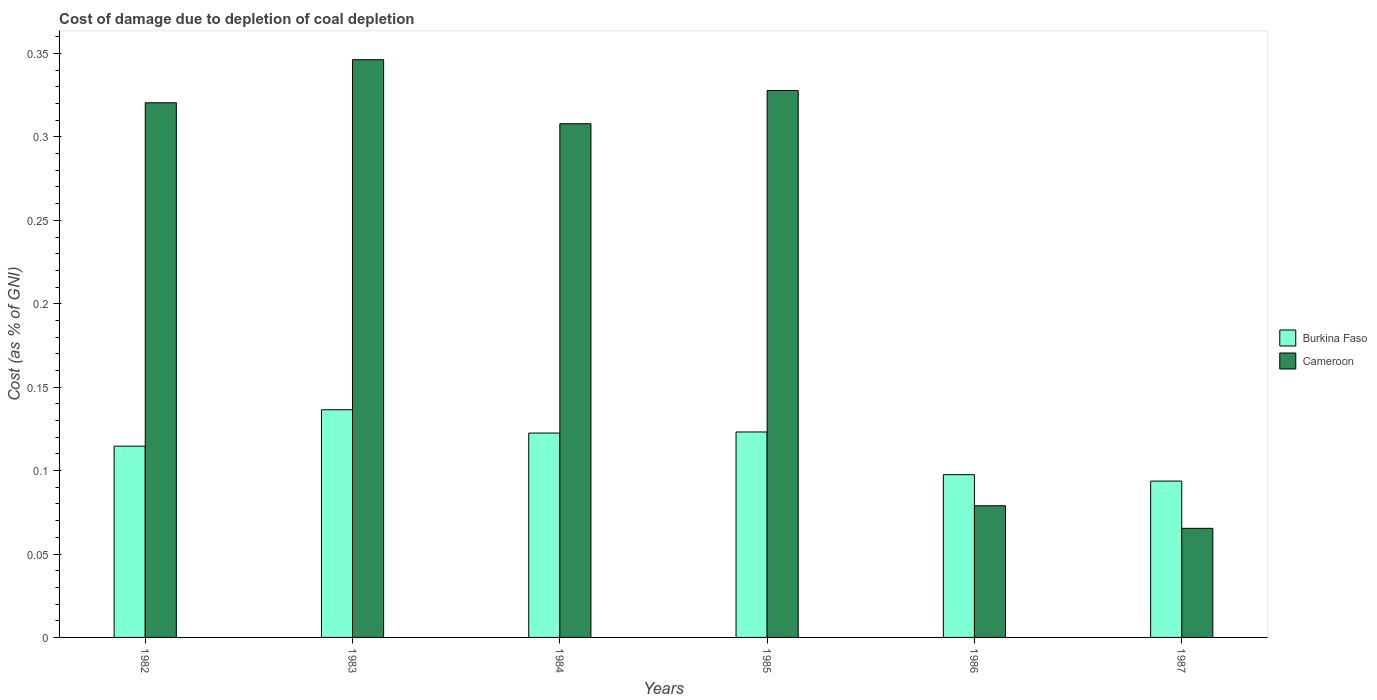How many groups of bars are there?
Your answer should be compact. 6. Are the number of bars per tick equal to the number of legend labels?
Provide a short and direct response. Yes. Are the number of bars on each tick of the X-axis equal?
Give a very brief answer. Yes. How many bars are there on the 3rd tick from the left?
Offer a very short reply. 2. What is the label of the 3rd group of bars from the left?
Your response must be concise. 1984. In how many cases, is the number of bars for a given year not equal to the number of legend labels?
Your response must be concise. 0. What is the cost of damage caused due to coal depletion in Burkina Faso in 1986?
Provide a succinct answer. 0.1. Across all years, what is the maximum cost of damage caused due to coal depletion in Burkina Faso?
Offer a terse response. 0.14. Across all years, what is the minimum cost of damage caused due to coal depletion in Burkina Faso?
Your response must be concise. 0.09. In which year was the cost of damage caused due to coal depletion in Burkina Faso minimum?
Your response must be concise. 1987. What is the total cost of damage caused due to coal depletion in Cameroon in the graph?
Offer a terse response. 1.45. What is the difference between the cost of damage caused due to coal depletion in Cameroon in 1985 and that in 1987?
Provide a short and direct response. 0.26. What is the difference between the cost of damage caused due to coal depletion in Cameroon in 1986 and the cost of damage caused due to coal depletion in Burkina Faso in 1987?
Keep it short and to the point. -0.01. What is the average cost of damage caused due to coal depletion in Cameroon per year?
Ensure brevity in your answer.  0.24. In the year 1987, what is the difference between the cost of damage caused due to coal depletion in Cameroon and cost of damage caused due to coal depletion in Burkina Faso?
Your response must be concise. -0.03. In how many years, is the cost of damage caused due to coal depletion in Burkina Faso greater than 0.32000000000000006 %?
Make the answer very short. 0. What is the ratio of the cost of damage caused due to coal depletion in Cameroon in 1984 to that in 1987?
Provide a succinct answer. 4.71. Is the cost of damage caused due to coal depletion in Burkina Faso in 1982 less than that in 1987?
Your answer should be very brief. No. What is the difference between the highest and the second highest cost of damage caused due to coal depletion in Burkina Faso?
Keep it short and to the point. 0.01. What is the difference between the highest and the lowest cost of damage caused due to coal depletion in Cameroon?
Provide a short and direct response. 0.28. Is the sum of the cost of damage caused due to coal depletion in Burkina Faso in 1986 and 1987 greater than the maximum cost of damage caused due to coal depletion in Cameroon across all years?
Provide a short and direct response. No. What does the 1st bar from the left in 1985 represents?
Ensure brevity in your answer.  Burkina Faso. What does the 2nd bar from the right in 1987 represents?
Provide a short and direct response. Burkina Faso. How many bars are there?
Provide a succinct answer. 12. What is the difference between two consecutive major ticks on the Y-axis?
Your answer should be very brief. 0.05. Are the values on the major ticks of Y-axis written in scientific E-notation?
Provide a short and direct response. No. Does the graph contain grids?
Your answer should be very brief. No. What is the title of the graph?
Offer a terse response. Cost of damage due to depletion of coal depletion. Does "Fragile and conflict affected situations" appear as one of the legend labels in the graph?
Give a very brief answer. No. What is the label or title of the Y-axis?
Ensure brevity in your answer.  Cost (as % of GNI). What is the Cost (as % of GNI) in Burkina Faso in 1982?
Give a very brief answer. 0.11. What is the Cost (as % of GNI) in Cameroon in 1982?
Ensure brevity in your answer.  0.32. What is the Cost (as % of GNI) in Burkina Faso in 1983?
Your answer should be compact. 0.14. What is the Cost (as % of GNI) in Cameroon in 1983?
Provide a short and direct response. 0.35. What is the Cost (as % of GNI) of Burkina Faso in 1984?
Your answer should be compact. 0.12. What is the Cost (as % of GNI) in Cameroon in 1984?
Offer a very short reply. 0.31. What is the Cost (as % of GNI) in Burkina Faso in 1985?
Provide a short and direct response. 0.12. What is the Cost (as % of GNI) of Cameroon in 1985?
Your answer should be compact. 0.33. What is the Cost (as % of GNI) in Burkina Faso in 1986?
Keep it short and to the point. 0.1. What is the Cost (as % of GNI) in Cameroon in 1986?
Offer a very short reply. 0.08. What is the Cost (as % of GNI) in Burkina Faso in 1987?
Give a very brief answer. 0.09. What is the Cost (as % of GNI) of Cameroon in 1987?
Your answer should be very brief. 0.07. Across all years, what is the maximum Cost (as % of GNI) in Burkina Faso?
Offer a very short reply. 0.14. Across all years, what is the maximum Cost (as % of GNI) of Cameroon?
Your answer should be very brief. 0.35. Across all years, what is the minimum Cost (as % of GNI) of Burkina Faso?
Offer a very short reply. 0.09. Across all years, what is the minimum Cost (as % of GNI) in Cameroon?
Your response must be concise. 0.07. What is the total Cost (as % of GNI) of Burkina Faso in the graph?
Offer a terse response. 0.69. What is the total Cost (as % of GNI) of Cameroon in the graph?
Your answer should be compact. 1.45. What is the difference between the Cost (as % of GNI) in Burkina Faso in 1982 and that in 1983?
Give a very brief answer. -0.02. What is the difference between the Cost (as % of GNI) in Cameroon in 1982 and that in 1983?
Provide a succinct answer. -0.03. What is the difference between the Cost (as % of GNI) of Burkina Faso in 1982 and that in 1984?
Your answer should be compact. -0.01. What is the difference between the Cost (as % of GNI) of Cameroon in 1982 and that in 1984?
Your answer should be very brief. 0.01. What is the difference between the Cost (as % of GNI) of Burkina Faso in 1982 and that in 1985?
Offer a terse response. -0.01. What is the difference between the Cost (as % of GNI) of Cameroon in 1982 and that in 1985?
Provide a short and direct response. -0.01. What is the difference between the Cost (as % of GNI) in Burkina Faso in 1982 and that in 1986?
Your answer should be very brief. 0.02. What is the difference between the Cost (as % of GNI) of Cameroon in 1982 and that in 1986?
Your response must be concise. 0.24. What is the difference between the Cost (as % of GNI) in Burkina Faso in 1982 and that in 1987?
Ensure brevity in your answer.  0.02. What is the difference between the Cost (as % of GNI) in Cameroon in 1982 and that in 1987?
Your answer should be compact. 0.26. What is the difference between the Cost (as % of GNI) in Burkina Faso in 1983 and that in 1984?
Your answer should be compact. 0.01. What is the difference between the Cost (as % of GNI) of Cameroon in 1983 and that in 1984?
Offer a terse response. 0.04. What is the difference between the Cost (as % of GNI) in Burkina Faso in 1983 and that in 1985?
Ensure brevity in your answer.  0.01. What is the difference between the Cost (as % of GNI) of Cameroon in 1983 and that in 1985?
Offer a terse response. 0.02. What is the difference between the Cost (as % of GNI) in Burkina Faso in 1983 and that in 1986?
Make the answer very short. 0.04. What is the difference between the Cost (as % of GNI) in Cameroon in 1983 and that in 1986?
Your answer should be very brief. 0.27. What is the difference between the Cost (as % of GNI) of Burkina Faso in 1983 and that in 1987?
Give a very brief answer. 0.04. What is the difference between the Cost (as % of GNI) of Cameroon in 1983 and that in 1987?
Ensure brevity in your answer.  0.28. What is the difference between the Cost (as % of GNI) of Burkina Faso in 1984 and that in 1985?
Your answer should be compact. -0. What is the difference between the Cost (as % of GNI) of Cameroon in 1984 and that in 1985?
Your response must be concise. -0.02. What is the difference between the Cost (as % of GNI) of Burkina Faso in 1984 and that in 1986?
Make the answer very short. 0.02. What is the difference between the Cost (as % of GNI) in Cameroon in 1984 and that in 1986?
Your response must be concise. 0.23. What is the difference between the Cost (as % of GNI) in Burkina Faso in 1984 and that in 1987?
Give a very brief answer. 0.03. What is the difference between the Cost (as % of GNI) in Cameroon in 1984 and that in 1987?
Ensure brevity in your answer.  0.24. What is the difference between the Cost (as % of GNI) in Burkina Faso in 1985 and that in 1986?
Keep it short and to the point. 0.03. What is the difference between the Cost (as % of GNI) in Cameroon in 1985 and that in 1986?
Your answer should be compact. 0.25. What is the difference between the Cost (as % of GNI) of Burkina Faso in 1985 and that in 1987?
Your response must be concise. 0.03. What is the difference between the Cost (as % of GNI) of Cameroon in 1985 and that in 1987?
Ensure brevity in your answer.  0.26. What is the difference between the Cost (as % of GNI) of Burkina Faso in 1986 and that in 1987?
Provide a succinct answer. 0. What is the difference between the Cost (as % of GNI) in Cameroon in 1986 and that in 1987?
Give a very brief answer. 0.01. What is the difference between the Cost (as % of GNI) in Burkina Faso in 1982 and the Cost (as % of GNI) in Cameroon in 1983?
Offer a very short reply. -0.23. What is the difference between the Cost (as % of GNI) of Burkina Faso in 1982 and the Cost (as % of GNI) of Cameroon in 1984?
Keep it short and to the point. -0.19. What is the difference between the Cost (as % of GNI) in Burkina Faso in 1982 and the Cost (as % of GNI) in Cameroon in 1985?
Make the answer very short. -0.21. What is the difference between the Cost (as % of GNI) of Burkina Faso in 1982 and the Cost (as % of GNI) of Cameroon in 1986?
Provide a succinct answer. 0.04. What is the difference between the Cost (as % of GNI) in Burkina Faso in 1982 and the Cost (as % of GNI) in Cameroon in 1987?
Give a very brief answer. 0.05. What is the difference between the Cost (as % of GNI) in Burkina Faso in 1983 and the Cost (as % of GNI) in Cameroon in 1984?
Your answer should be compact. -0.17. What is the difference between the Cost (as % of GNI) in Burkina Faso in 1983 and the Cost (as % of GNI) in Cameroon in 1985?
Keep it short and to the point. -0.19. What is the difference between the Cost (as % of GNI) of Burkina Faso in 1983 and the Cost (as % of GNI) of Cameroon in 1986?
Your response must be concise. 0.06. What is the difference between the Cost (as % of GNI) of Burkina Faso in 1983 and the Cost (as % of GNI) of Cameroon in 1987?
Give a very brief answer. 0.07. What is the difference between the Cost (as % of GNI) in Burkina Faso in 1984 and the Cost (as % of GNI) in Cameroon in 1985?
Offer a terse response. -0.21. What is the difference between the Cost (as % of GNI) in Burkina Faso in 1984 and the Cost (as % of GNI) in Cameroon in 1986?
Keep it short and to the point. 0.04. What is the difference between the Cost (as % of GNI) in Burkina Faso in 1984 and the Cost (as % of GNI) in Cameroon in 1987?
Make the answer very short. 0.06. What is the difference between the Cost (as % of GNI) in Burkina Faso in 1985 and the Cost (as % of GNI) in Cameroon in 1986?
Keep it short and to the point. 0.04. What is the difference between the Cost (as % of GNI) in Burkina Faso in 1985 and the Cost (as % of GNI) in Cameroon in 1987?
Your answer should be very brief. 0.06. What is the difference between the Cost (as % of GNI) in Burkina Faso in 1986 and the Cost (as % of GNI) in Cameroon in 1987?
Make the answer very short. 0.03. What is the average Cost (as % of GNI) of Burkina Faso per year?
Your answer should be compact. 0.11. What is the average Cost (as % of GNI) of Cameroon per year?
Your response must be concise. 0.24. In the year 1982, what is the difference between the Cost (as % of GNI) of Burkina Faso and Cost (as % of GNI) of Cameroon?
Give a very brief answer. -0.21. In the year 1983, what is the difference between the Cost (as % of GNI) in Burkina Faso and Cost (as % of GNI) in Cameroon?
Provide a succinct answer. -0.21. In the year 1984, what is the difference between the Cost (as % of GNI) in Burkina Faso and Cost (as % of GNI) in Cameroon?
Provide a short and direct response. -0.19. In the year 1985, what is the difference between the Cost (as % of GNI) of Burkina Faso and Cost (as % of GNI) of Cameroon?
Ensure brevity in your answer.  -0.2. In the year 1986, what is the difference between the Cost (as % of GNI) in Burkina Faso and Cost (as % of GNI) in Cameroon?
Your answer should be very brief. 0.02. In the year 1987, what is the difference between the Cost (as % of GNI) in Burkina Faso and Cost (as % of GNI) in Cameroon?
Your answer should be very brief. 0.03. What is the ratio of the Cost (as % of GNI) in Burkina Faso in 1982 to that in 1983?
Make the answer very short. 0.84. What is the ratio of the Cost (as % of GNI) of Cameroon in 1982 to that in 1983?
Your answer should be very brief. 0.93. What is the ratio of the Cost (as % of GNI) in Burkina Faso in 1982 to that in 1984?
Ensure brevity in your answer.  0.94. What is the ratio of the Cost (as % of GNI) of Cameroon in 1982 to that in 1984?
Ensure brevity in your answer.  1.04. What is the ratio of the Cost (as % of GNI) in Burkina Faso in 1982 to that in 1985?
Your answer should be compact. 0.93. What is the ratio of the Cost (as % of GNI) of Cameroon in 1982 to that in 1985?
Keep it short and to the point. 0.98. What is the ratio of the Cost (as % of GNI) of Burkina Faso in 1982 to that in 1986?
Offer a very short reply. 1.18. What is the ratio of the Cost (as % of GNI) of Cameroon in 1982 to that in 1986?
Provide a succinct answer. 4.06. What is the ratio of the Cost (as % of GNI) in Burkina Faso in 1982 to that in 1987?
Provide a succinct answer. 1.22. What is the ratio of the Cost (as % of GNI) in Cameroon in 1982 to that in 1987?
Provide a succinct answer. 4.9. What is the ratio of the Cost (as % of GNI) of Burkina Faso in 1983 to that in 1984?
Offer a terse response. 1.11. What is the ratio of the Cost (as % of GNI) of Cameroon in 1983 to that in 1984?
Ensure brevity in your answer.  1.12. What is the ratio of the Cost (as % of GNI) in Burkina Faso in 1983 to that in 1985?
Offer a terse response. 1.11. What is the ratio of the Cost (as % of GNI) in Cameroon in 1983 to that in 1985?
Provide a succinct answer. 1.06. What is the ratio of the Cost (as % of GNI) of Burkina Faso in 1983 to that in 1986?
Give a very brief answer. 1.4. What is the ratio of the Cost (as % of GNI) in Cameroon in 1983 to that in 1986?
Provide a short and direct response. 4.39. What is the ratio of the Cost (as % of GNI) of Burkina Faso in 1983 to that in 1987?
Give a very brief answer. 1.46. What is the ratio of the Cost (as % of GNI) in Cameroon in 1983 to that in 1987?
Ensure brevity in your answer.  5.3. What is the ratio of the Cost (as % of GNI) in Burkina Faso in 1984 to that in 1985?
Provide a succinct answer. 0.99. What is the ratio of the Cost (as % of GNI) of Cameroon in 1984 to that in 1985?
Give a very brief answer. 0.94. What is the ratio of the Cost (as % of GNI) in Burkina Faso in 1984 to that in 1986?
Your response must be concise. 1.26. What is the ratio of the Cost (as % of GNI) of Cameroon in 1984 to that in 1986?
Your response must be concise. 3.9. What is the ratio of the Cost (as % of GNI) of Burkina Faso in 1984 to that in 1987?
Make the answer very short. 1.31. What is the ratio of the Cost (as % of GNI) in Cameroon in 1984 to that in 1987?
Offer a terse response. 4.71. What is the ratio of the Cost (as % of GNI) of Burkina Faso in 1985 to that in 1986?
Provide a short and direct response. 1.26. What is the ratio of the Cost (as % of GNI) of Cameroon in 1985 to that in 1986?
Provide a short and direct response. 4.15. What is the ratio of the Cost (as % of GNI) of Burkina Faso in 1985 to that in 1987?
Give a very brief answer. 1.31. What is the ratio of the Cost (as % of GNI) of Cameroon in 1985 to that in 1987?
Your answer should be compact. 5.01. What is the ratio of the Cost (as % of GNI) in Burkina Faso in 1986 to that in 1987?
Keep it short and to the point. 1.04. What is the ratio of the Cost (as % of GNI) of Cameroon in 1986 to that in 1987?
Your answer should be compact. 1.21. What is the difference between the highest and the second highest Cost (as % of GNI) in Burkina Faso?
Offer a very short reply. 0.01. What is the difference between the highest and the second highest Cost (as % of GNI) of Cameroon?
Give a very brief answer. 0.02. What is the difference between the highest and the lowest Cost (as % of GNI) of Burkina Faso?
Your response must be concise. 0.04. What is the difference between the highest and the lowest Cost (as % of GNI) of Cameroon?
Ensure brevity in your answer.  0.28. 